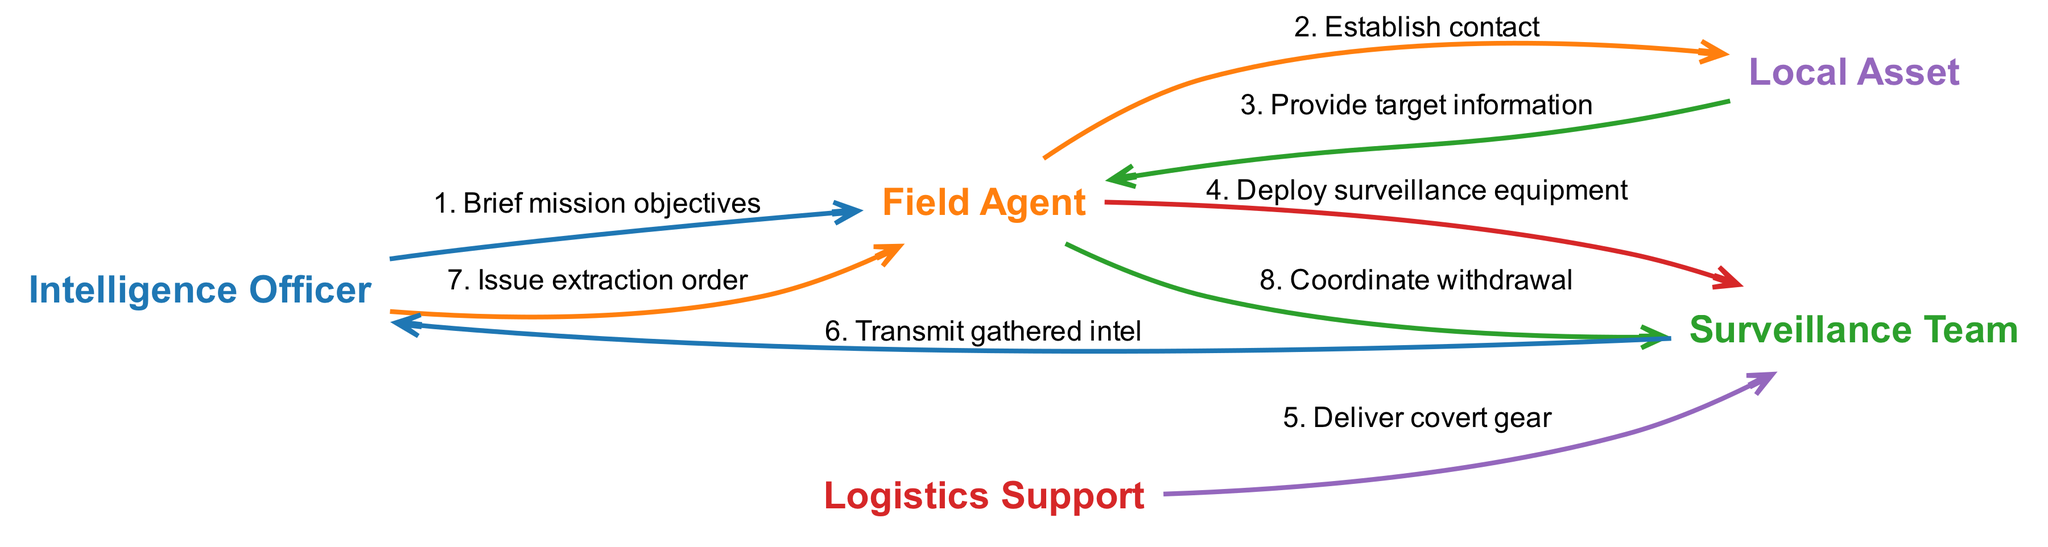What is the first action in the sequence? The first action involves the Intelligence Officer briefing the Field Agent about the mission objectives. This can be derived from the initial step listed in the sequence, which outlines the action taken by the Intelligence Officer towards the Field Agent.
Answer: Brief mission objectives How many actors are involved in the deployment operation? There are five distinct actors identified in the diagram: Intelligence Officer, Field Agent, Surveillance Team, Logistics Support, and Local Asset. This can be directly counted from the list provided in the actors section.
Answer: Five What action follows the provision of target information? After Local Asset provides the target information to the Field Agent, the next action is the Field Agent deploying surveillance equipment to the Surveillance Team. This progression is indicated by the sequence order in the diagram.
Answer: Deploy surveillance equipment Who issues the extraction order? The extraction order is issued by the Intelligence Officer, as shown in the subsequent action where the Intelligence Officer communicates this directive to the Field Agent in the sequence.
Answer: Intelligence Officer What is the relationship between the Field Agent and the Surveillance Team? The Field Agent coordinates with the Surveillance Team twice: once to deploy surveillance equipment and again to coordinate withdrawal after gathering intel. This indicates a collaborative relationship throughout the deployment operation.
Answer: Coordinate withdrawal What is the total number of actions depicted in the sequence? Counting all actions listed in the sequence, there are eight distinct actions that describe the various steps taken during the operation. This is determined by counting each individual action outlined in the sequence.
Answer: Eight What type of gear does the Logistics Support deliver? The Logistics Support delivers covert gear, as specified in the action highlighted in the sequence. This is explicitly mentioned as the delivery accompanied by the Logistics Support's interaction with the Surveillance Team.
Answer: Covert gear Which actor provides target information? The Local Asset is responsible for providing the target information to the Field Agent after establishing contact. This interaction is clearly delineated in the sequence, identifying the Local Asset's role in gathering intelligence.
Answer: Local Asset 